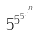Convert formula to latex. <formula><loc_0><loc_0><loc_500><loc_500>5 ^ { 5 ^ { 5 ^ { . ^ { . ^ { n } } } } }</formula> 